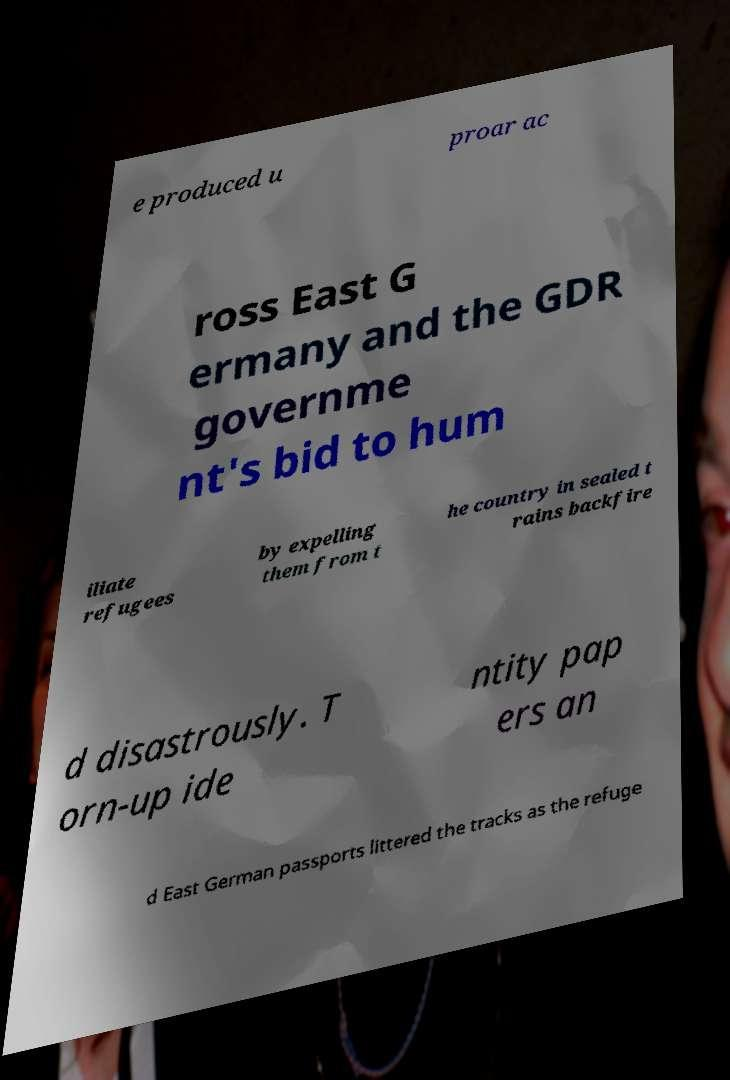I need the written content from this picture converted into text. Can you do that? e produced u proar ac ross East G ermany and the GDR governme nt's bid to hum iliate refugees by expelling them from t he country in sealed t rains backfire d disastrously. T orn-up ide ntity pap ers an d East German passports littered the tracks as the refuge 